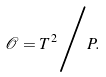Convert formula to latex. <formula><loc_0><loc_0><loc_500><loc_500>\mathcal { O } = T ^ { 2 } \Big { / } P .</formula> 